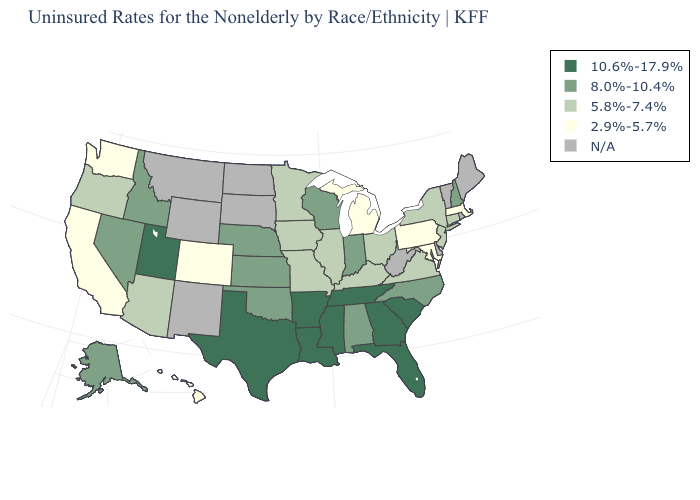Name the states that have a value in the range 2.9%-5.7%?
Write a very short answer. California, Colorado, Hawaii, Maryland, Massachusetts, Michigan, Pennsylvania, Washington. Does the first symbol in the legend represent the smallest category?
Keep it brief. No. What is the value of Louisiana?
Give a very brief answer. 10.6%-17.9%. Name the states that have a value in the range 8.0%-10.4%?
Answer briefly. Alabama, Alaska, Idaho, Indiana, Kansas, Nebraska, Nevada, New Hampshire, North Carolina, Oklahoma, Wisconsin. Does Massachusetts have the lowest value in the Northeast?
Concise answer only. Yes. Name the states that have a value in the range N/A?
Concise answer only. Delaware, Maine, Montana, New Mexico, North Dakota, Rhode Island, South Dakota, Vermont, West Virginia, Wyoming. How many symbols are there in the legend?
Give a very brief answer. 5. What is the value of Iowa?
Write a very short answer. 5.8%-7.4%. What is the value of Wisconsin?
Write a very short answer. 8.0%-10.4%. Name the states that have a value in the range 5.8%-7.4%?
Concise answer only. Arizona, Connecticut, Illinois, Iowa, Kentucky, Minnesota, Missouri, New Jersey, New York, Ohio, Oregon, Virginia. Name the states that have a value in the range N/A?
Keep it brief. Delaware, Maine, Montana, New Mexico, North Dakota, Rhode Island, South Dakota, Vermont, West Virginia, Wyoming. Name the states that have a value in the range 2.9%-5.7%?
Be succinct. California, Colorado, Hawaii, Maryland, Massachusetts, Michigan, Pennsylvania, Washington. Name the states that have a value in the range N/A?
Answer briefly. Delaware, Maine, Montana, New Mexico, North Dakota, Rhode Island, South Dakota, Vermont, West Virginia, Wyoming. 